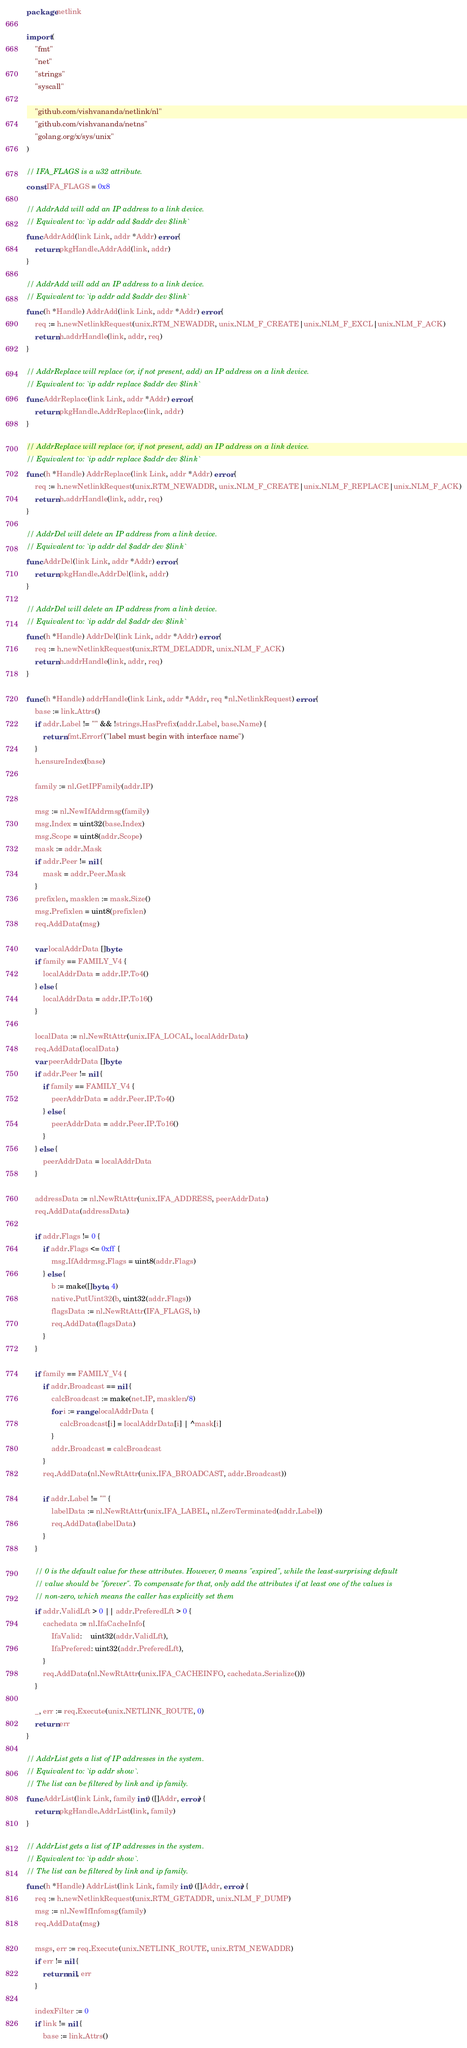Convert code to text. <code><loc_0><loc_0><loc_500><loc_500><_Go_>package netlink

import (
	"fmt"
	"net"
	"strings"
	"syscall"

	"github.com/vishvananda/netlink/nl"
	"github.com/vishvananda/netns"
	"golang.org/x/sys/unix"
)

// IFA_FLAGS is a u32 attribute.
const IFA_FLAGS = 0x8

// AddrAdd will add an IP address to a link device.
// Equivalent to: `ip addr add $addr dev $link`
func AddrAdd(link Link, addr *Addr) error {
	return pkgHandle.AddrAdd(link, addr)
}

// AddrAdd will add an IP address to a link device.
// Equivalent to: `ip addr add $addr dev $link`
func (h *Handle) AddrAdd(link Link, addr *Addr) error {
	req := h.newNetlinkRequest(unix.RTM_NEWADDR, unix.NLM_F_CREATE|unix.NLM_F_EXCL|unix.NLM_F_ACK)
	return h.addrHandle(link, addr, req)
}

// AddrReplace will replace (or, if not present, add) an IP address on a link device.
// Equivalent to: `ip addr replace $addr dev $link`
func AddrReplace(link Link, addr *Addr) error {
	return pkgHandle.AddrReplace(link, addr)
}

// AddrReplace will replace (or, if not present, add) an IP address on a link device.
// Equivalent to: `ip addr replace $addr dev $link`
func (h *Handle) AddrReplace(link Link, addr *Addr) error {
	req := h.newNetlinkRequest(unix.RTM_NEWADDR, unix.NLM_F_CREATE|unix.NLM_F_REPLACE|unix.NLM_F_ACK)
	return h.addrHandle(link, addr, req)
}

// AddrDel will delete an IP address from a link device.
// Equivalent to: `ip addr del $addr dev $link`
func AddrDel(link Link, addr *Addr) error {
	return pkgHandle.AddrDel(link, addr)
}

// AddrDel will delete an IP address from a link device.
// Equivalent to: `ip addr del $addr dev $link`
func (h *Handle) AddrDel(link Link, addr *Addr) error {
	req := h.newNetlinkRequest(unix.RTM_DELADDR, unix.NLM_F_ACK)
	return h.addrHandle(link, addr, req)
}

func (h *Handle) addrHandle(link Link, addr *Addr, req *nl.NetlinkRequest) error {
	base := link.Attrs()
	if addr.Label != "" && !strings.HasPrefix(addr.Label, base.Name) {
		return fmt.Errorf("label must begin with interface name")
	}
	h.ensureIndex(base)

	family := nl.GetIPFamily(addr.IP)

	msg := nl.NewIfAddrmsg(family)
	msg.Index = uint32(base.Index)
	msg.Scope = uint8(addr.Scope)
	mask := addr.Mask
	if addr.Peer != nil {
		mask = addr.Peer.Mask
	}
	prefixlen, masklen := mask.Size()
	msg.Prefixlen = uint8(prefixlen)
	req.AddData(msg)

	var localAddrData []byte
	if family == FAMILY_V4 {
		localAddrData = addr.IP.To4()
	} else {
		localAddrData = addr.IP.To16()
	}

	localData := nl.NewRtAttr(unix.IFA_LOCAL, localAddrData)
	req.AddData(localData)
	var peerAddrData []byte
	if addr.Peer != nil {
		if family == FAMILY_V4 {
			peerAddrData = addr.Peer.IP.To4()
		} else {
			peerAddrData = addr.Peer.IP.To16()
		}
	} else {
		peerAddrData = localAddrData
	}

	addressData := nl.NewRtAttr(unix.IFA_ADDRESS, peerAddrData)
	req.AddData(addressData)

	if addr.Flags != 0 {
		if addr.Flags <= 0xff {
			msg.IfAddrmsg.Flags = uint8(addr.Flags)
		} else {
			b := make([]byte, 4)
			native.PutUint32(b, uint32(addr.Flags))
			flagsData := nl.NewRtAttr(IFA_FLAGS, b)
			req.AddData(flagsData)
		}
	}

	if family == FAMILY_V4 {
		if addr.Broadcast == nil {
			calcBroadcast := make(net.IP, masklen/8)
			for i := range localAddrData {
				calcBroadcast[i] = localAddrData[i] | ^mask[i]
			}
			addr.Broadcast = calcBroadcast
		}
		req.AddData(nl.NewRtAttr(unix.IFA_BROADCAST, addr.Broadcast))

		if addr.Label != "" {
			labelData := nl.NewRtAttr(unix.IFA_LABEL, nl.ZeroTerminated(addr.Label))
			req.AddData(labelData)
		}
	}

	// 0 is the default value for these attributes. However, 0 means "expired", while the least-surprising default
	// value should be "forever". To compensate for that, only add the attributes if at least one of the values is
	// non-zero, which means the caller has explicitly set them
	if addr.ValidLft > 0 || addr.PreferedLft > 0 {
		cachedata := nl.IfaCacheInfo{
			IfaValid:    uint32(addr.ValidLft),
			IfaPrefered: uint32(addr.PreferedLft),
		}
		req.AddData(nl.NewRtAttr(unix.IFA_CACHEINFO, cachedata.Serialize()))
	}

	_, err := req.Execute(unix.NETLINK_ROUTE, 0)
	return err
}

// AddrList gets a list of IP addresses in the system.
// Equivalent to: `ip addr show`.
// The list can be filtered by link and ip family.
func AddrList(link Link, family int) ([]Addr, error) {
	return pkgHandle.AddrList(link, family)
}

// AddrList gets a list of IP addresses in the system.
// Equivalent to: `ip addr show`.
// The list can be filtered by link and ip family.
func (h *Handle) AddrList(link Link, family int) ([]Addr, error) {
	req := h.newNetlinkRequest(unix.RTM_GETADDR, unix.NLM_F_DUMP)
	msg := nl.NewIfInfomsg(family)
	req.AddData(msg)

	msgs, err := req.Execute(unix.NETLINK_ROUTE, unix.RTM_NEWADDR)
	if err != nil {
		return nil, err
	}

	indexFilter := 0
	if link != nil {
		base := link.Attrs()</code> 